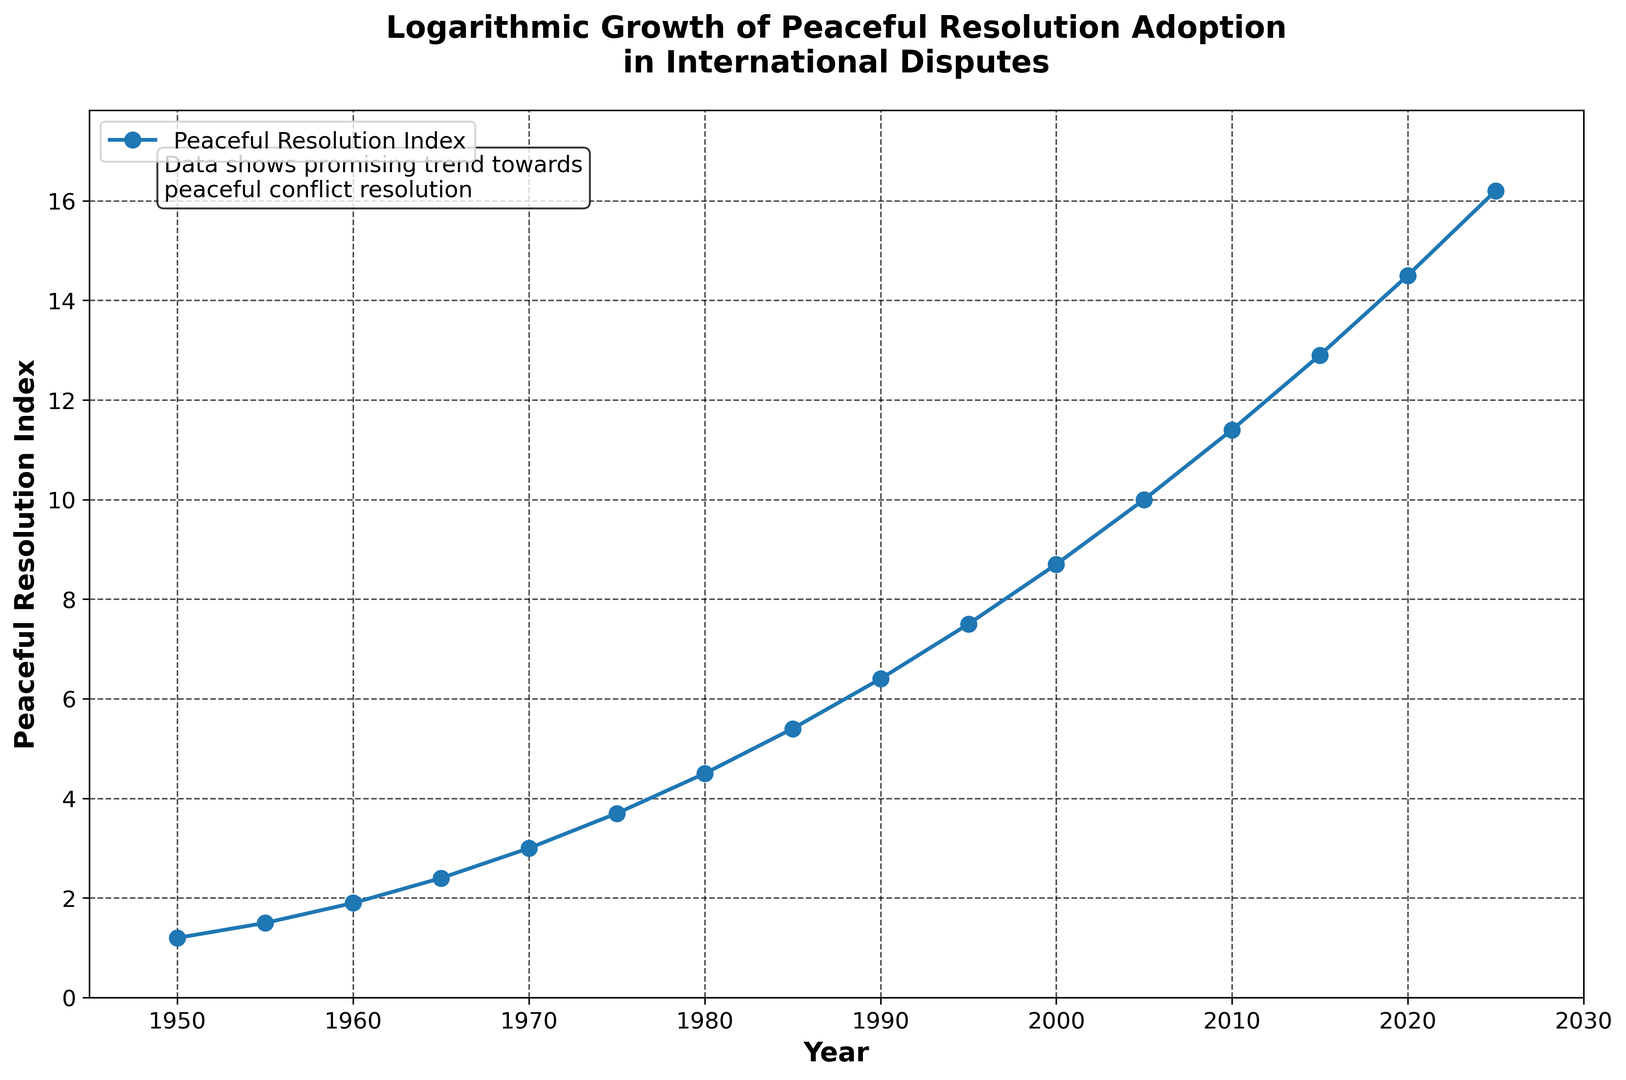Which year has the highest Peaceful Resolution Index? To find the year with the highest Peaceful Resolution Index, look at the line plot and identify the year where the index reaches its peak value. The peak value is at its highest in 2025.
Answer: 2025 What is the approximate average Peaceful Resolution Index from 1950 to 2025? To calculate the average Index, sum the values from 1950 to 2025 and then divide by the number of years. The sum of indices is 111.1, and there are 16 data points, so the average is 111.1 / 16.
Answer: 6.94 How much did the Peaceful Resolution Index increase from 1970 to 1980? To find the increase, subtract the 1970 index value from the 1980 index value. The values are 3.0 and 4.5, respectively, so the increase is 4.5 - 3.0.
Answer: 1.5 Between which two consecutive years is the largest increase in the Peaceful Resolution Index observed? To determine the largest increase between two consecutive years, compare the differences in the index for each interval. The largest difference, 2.4, occurs between 2000 (8.7) and 2005 (10.0).
Answer: Between 2000 and 2005 What general trend is observed in the Peaceful Resolution Index over the years shown? To identify the trend, observe the general direction of the line plot. The line steadily increases from 1950 to 2025 without any drops, indicating a consistent upward trend.
Answer: Consistent upward trend How does the Peaceful Resolution Index in 2020 compare to that in 1950? To compare the two indices, look at their respective values and note the difference. The index in 2020 is 14.5, while in 1950 it was 1.2, showing a substantial increase over the years.
Answer: The index in 2020 is much higher What is the compound annual growth rate (CAGR) of the Peaceful Resolution Index from 1950 to 2025? To calculate CAGR, use the formula CAGR = (End Value/Start Value)^(1/Number of Periods) - 1. Using the start value as 1.2 (1950) and end value as 16.2 (2025) over 75 years: CAGR = (16.2/1.2)^(1/75) - 1 = 0.043, or 4.3%.
Answer: 4.3% Is there any decade in which the Peaceful Resolution Index showed a decline? To determine if there is any decline, examine the line plot for any downward slopes within each decade. The line shows a continuous upward trend, indicating no declines.
Answer: No What is the median value of the Peaceful Resolution Index from the years shown? To find the median, list all the values in ascending order and find the middle one or the average of the two middle numbers. The median of the provided values is the average of the 8th and 9th values, (5.4 + 6.4) / 2.
Answer: 5.9 